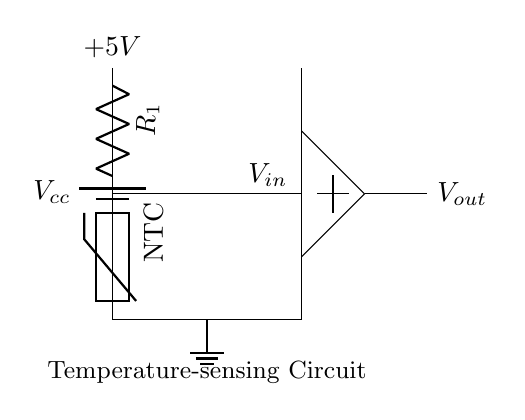What is the type of thermistor used in this circuit? The circuit diagram specifies an NTC thermistor, which is denoted next to the thermistor symbol in the diagram. NTC stands for "negative temperature coefficient," meaning its resistance decreases as temperature increases.
Answer: NTC What is the power supply voltage in this circuit? The circuit contains a battery labeled as Vcc, which shows that the power supply voltage is 5V, indicated by the label above the battery symbol.
Answer: 5V How many resistors are present in this circuit? There is one resistor (R1) shown in the circuit. The resistance is represented as R1 next to the resistor symbol. There are no other resistors indicated in the circuit.
Answer: One What kind of output does the operational amplifier generate? The operational amplifier is connected to the output node, labeled Vout. Operational amplifiers typically provide a voltage output based on the input from other components, in this case, the thermistor.
Answer: Voltage What happens to the output voltage as temperature increases? As temperature increases, the resistance of the NTC thermistor decreases, which alters the voltage divider input to the operational amplifier. This change results in an increase in output voltage in this configuration.
Answer: Increases What does the ground symbol indicate in this circuit? The ground symbol in the circuit represents the common reference point for the circuit's voltage levels. It indicates that this point serves as the return path for electrical current.
Answer: Common reference 